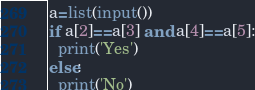Convert code to text. <code><loc_0><loc_0><loc_500><loc_500><_Python_>a=list(input())
if a[2]==a[3] and a[4]==a[5]:
  print('Yes')
else:
  print('No')
</code> 